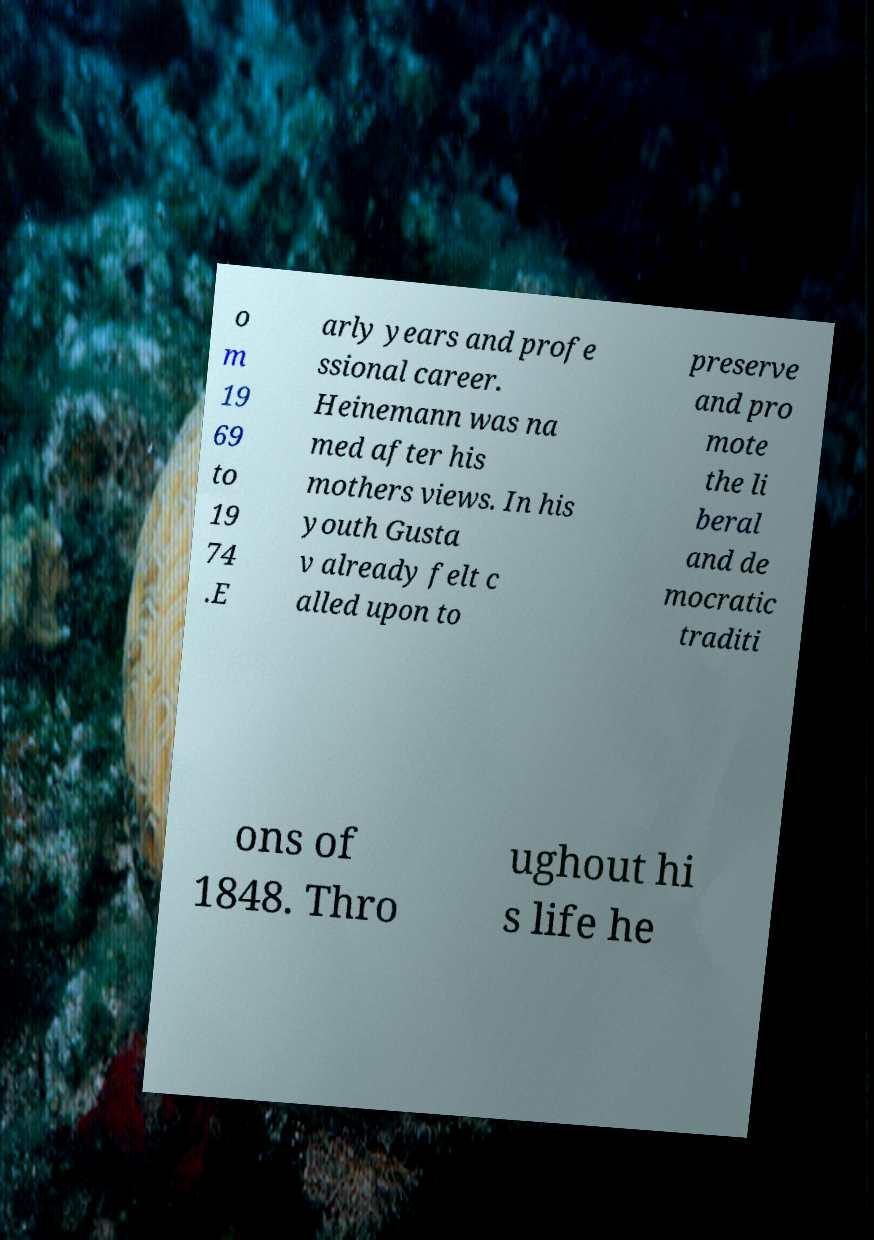There's text embedded in this image that I need extracted. Can you transcribe it verbatim? o m 19 69 to 19 74 .E arly years and profe ssional career. Heinemann was na med after his mothers views. In his youth Gusta v already felt c alled upon to preserve and pro mote the li beral and de mocratic traditi ons of 1848. Thro ughout hi s life he 